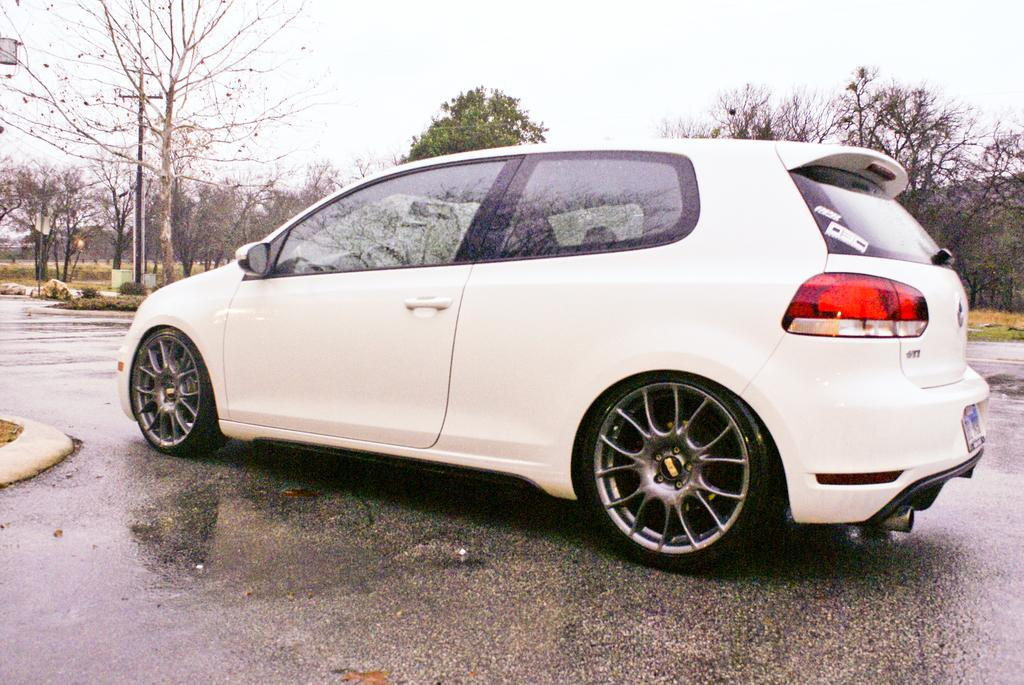What is the main subject of the image? There is a vehicle on the road in the image. What type of natural environment is visible in the image? There are many trees and a grassy land in the image. What can be seen in the sky in the image? The sky is visible in the image. How does the vehicle look for comfort in the image? The image does not show the vehicle looking for comfort; it is simply a vehicle on the road. 